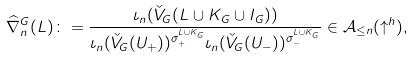Convert formula to latex. <formula><loc_0><loc_0><loc_500><loc_500>\widehat { \nabla } ^ { G } _ { n } ( L ) \colon = \frac { \iota _ { n } ( \check { V } _ { G } ( L \cup K _ { G } \cup I _ { G } ) ) } { \iota _ { n } ( \check { V } _ { G } ( U _ { + } ) ) ^ { \sigma ^ { L \cup K _ { G } } _ { + } } \iota _ { n } ( \check { V } _ { G } ( U _ { - } ) ) ^ { \sigma ^ { L \cup K _ { G } } _ { - } } } \in \mathcal { A } _ { \leq n } ( \uparrow ^ { h } ) ,</formula> 